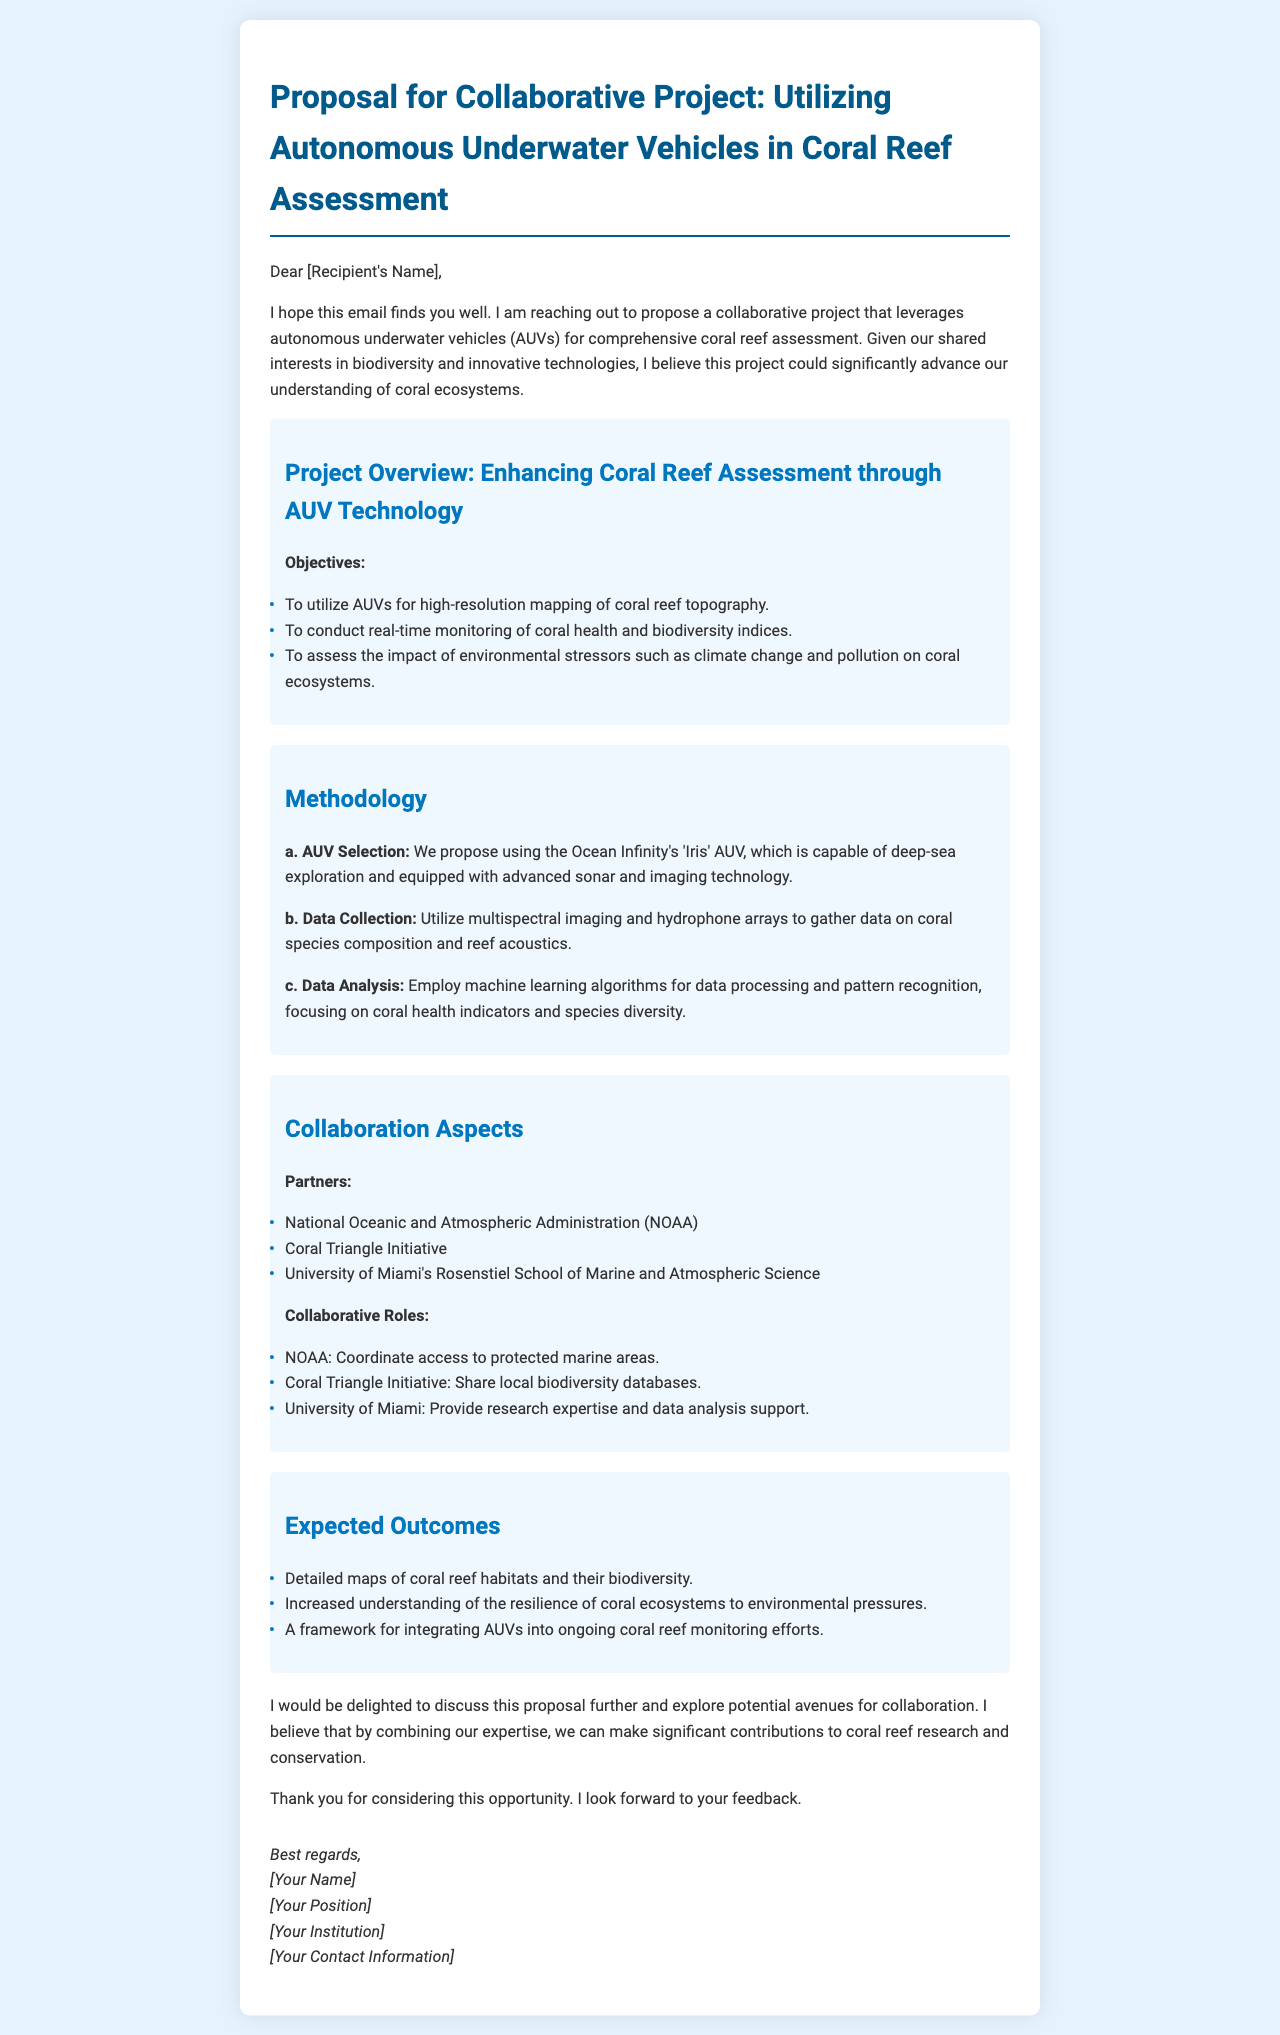What is the title of the proposal? The title of the proposal is stated at the beginning of the document.
Answer: Proposal for Collaborative Project: Utilizing Autonomous Underwater Vehicles in Coral Reef Assessment What technology is being proposed for coral reef assessment? The technology proposed in the document is specified in the title and the introduction.
Answer: Autonomous underwater vehicles (AUVs) Who is the AUV manufacturer mentioned in the proposal? The manufacturer of the AUV is provided in the methodology section.
Answer: Ocean Infinity What are the expected outcomes of the project? The expected outcomes are listed in a section dedicated to them, highlighting project benefits.
Answer: Detailed maps of coral reef habitats and their biodiversity Which partner is responsible for coordinating access to protected marine areas? The role of coordinating access is specified under "Collaborative Roles."
Answer: NOAA What is one method proposed for data collection? One method for data collection is detailed in the methodology section regarding specific techniques.
Answer: Multispectral imaging How many objectives are outlined in the project overview? The number of objectives mentioned can be counted in the project's objectives list.
Answer: Three What role does the University of Miami play in the collaboration? The document specifies the collaborative role assigned to the University of Miami.
Answer: Provide research expertise and data analysis support What is the primary aim of utilizing AUVs according to the proposal? The primary aim is described in the introduction and the project overview.
Answer: To conduct real-time monitoring of coral health and biodiversity indices 